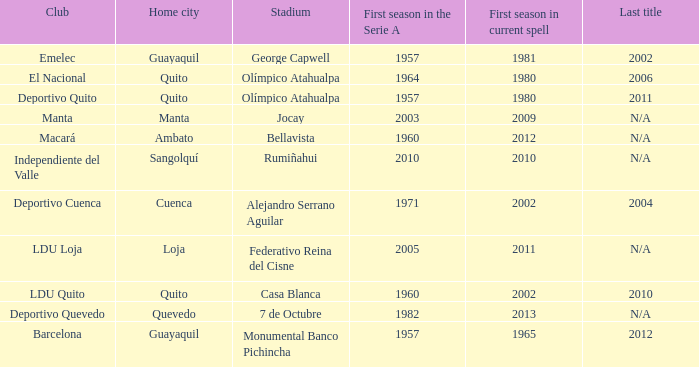Name the first season in the series for 2006 1964.0. 